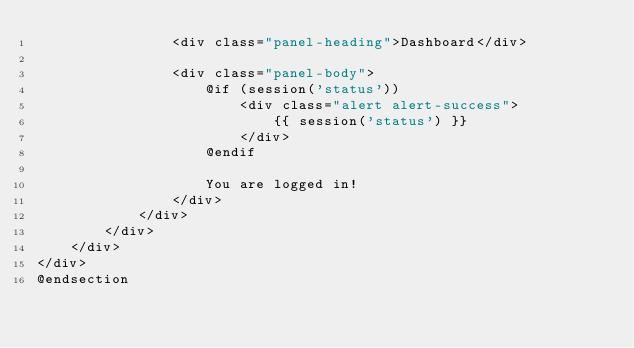<code> <loc_0><loc_0><loc_500><loc_500><_PHP_>                <div class="panel-heading">Dashboard</div>

                <div class="panel-body">
                    @if (session('status'))
                        <div class="alert alert-success">
                            {{ session('status') }}
                        </div>
                    @endif

                    You are logged in!
                </div>
            </div>
        </div>
    </div>
</div>
@endsection
</code> 